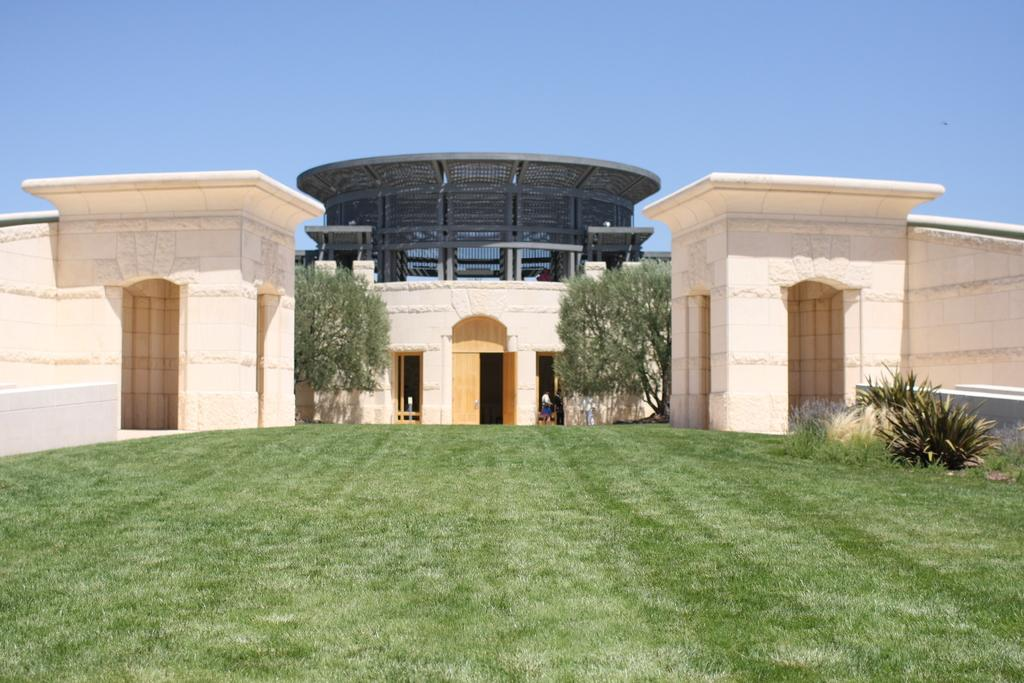What type of ground surface is visible in the image? There is grass on the ground in the image. What can be seen in the background of the image? There are plants, trees, buildings, and architecture in the background. What color is the sky in the image? The sky is blue in the image. Reasoning: Let' Let's think step by step in order to produce the conversation. We start by identifying the ground surface, which is grass. Then, we describe the background, which includes plants, trees, buildings, and architecture. Finally, we mention the color of the sky, which is blue. Each question is designed to elicit a specific detail about the image that is known from the provided facts. Absurd Question/Answer: What type of appliance can be seen in the image? There is no appliance present in the image. Can you describe the rod used for copying documents in the image? There is no rod or document copying activity depicted in the image. 